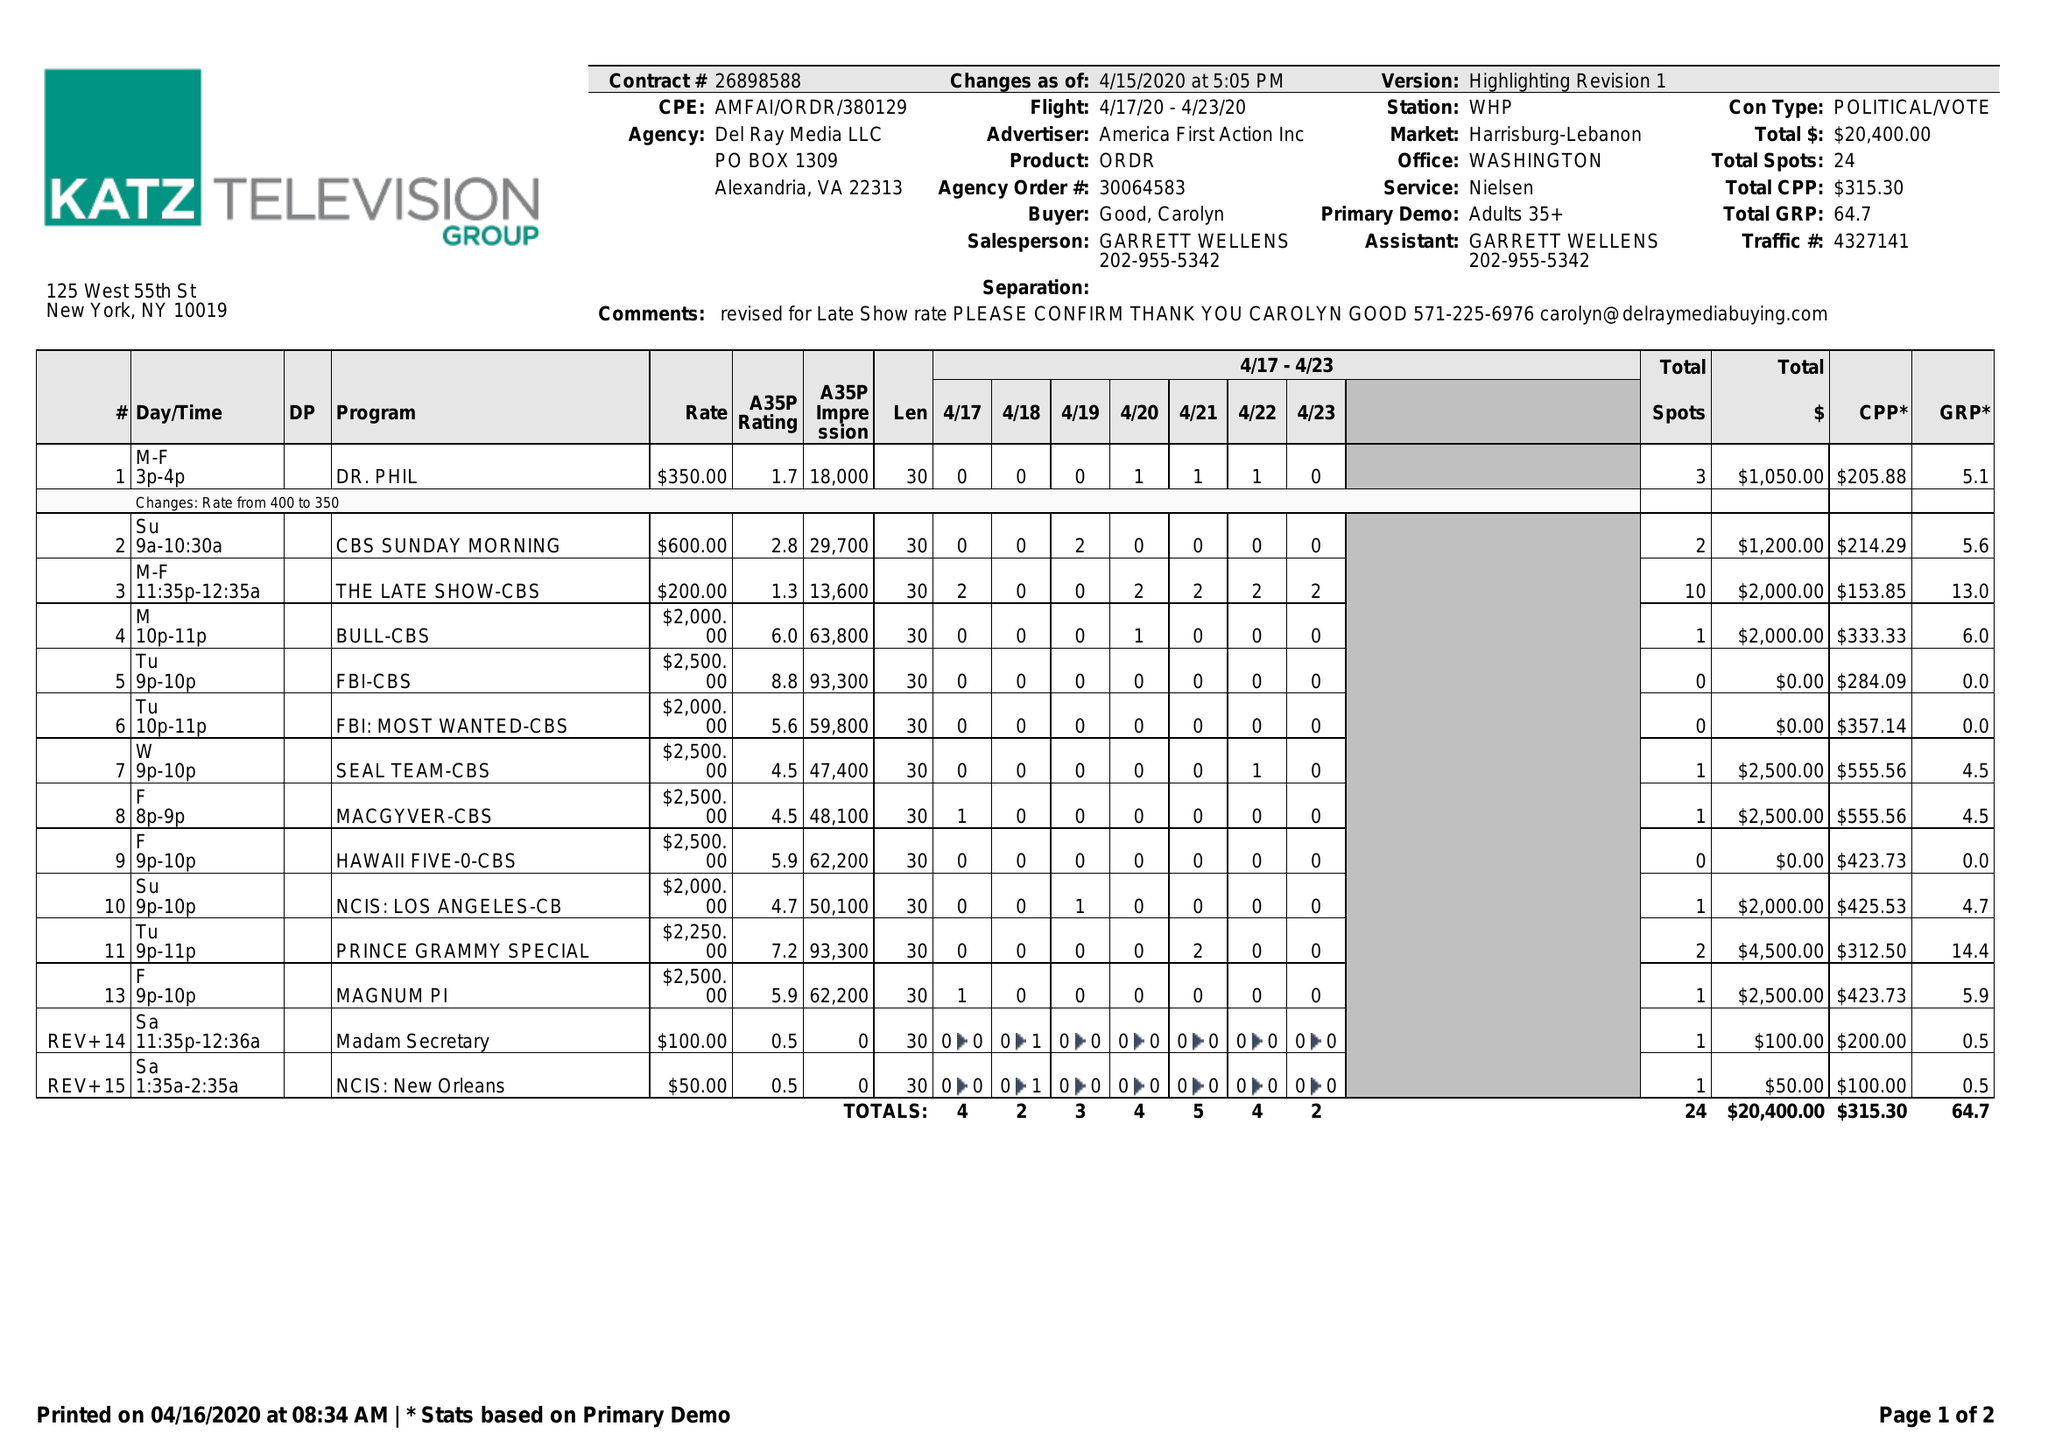What is the value for the flight_from?
Answer the question using a single word or phrase. 04/17/20 